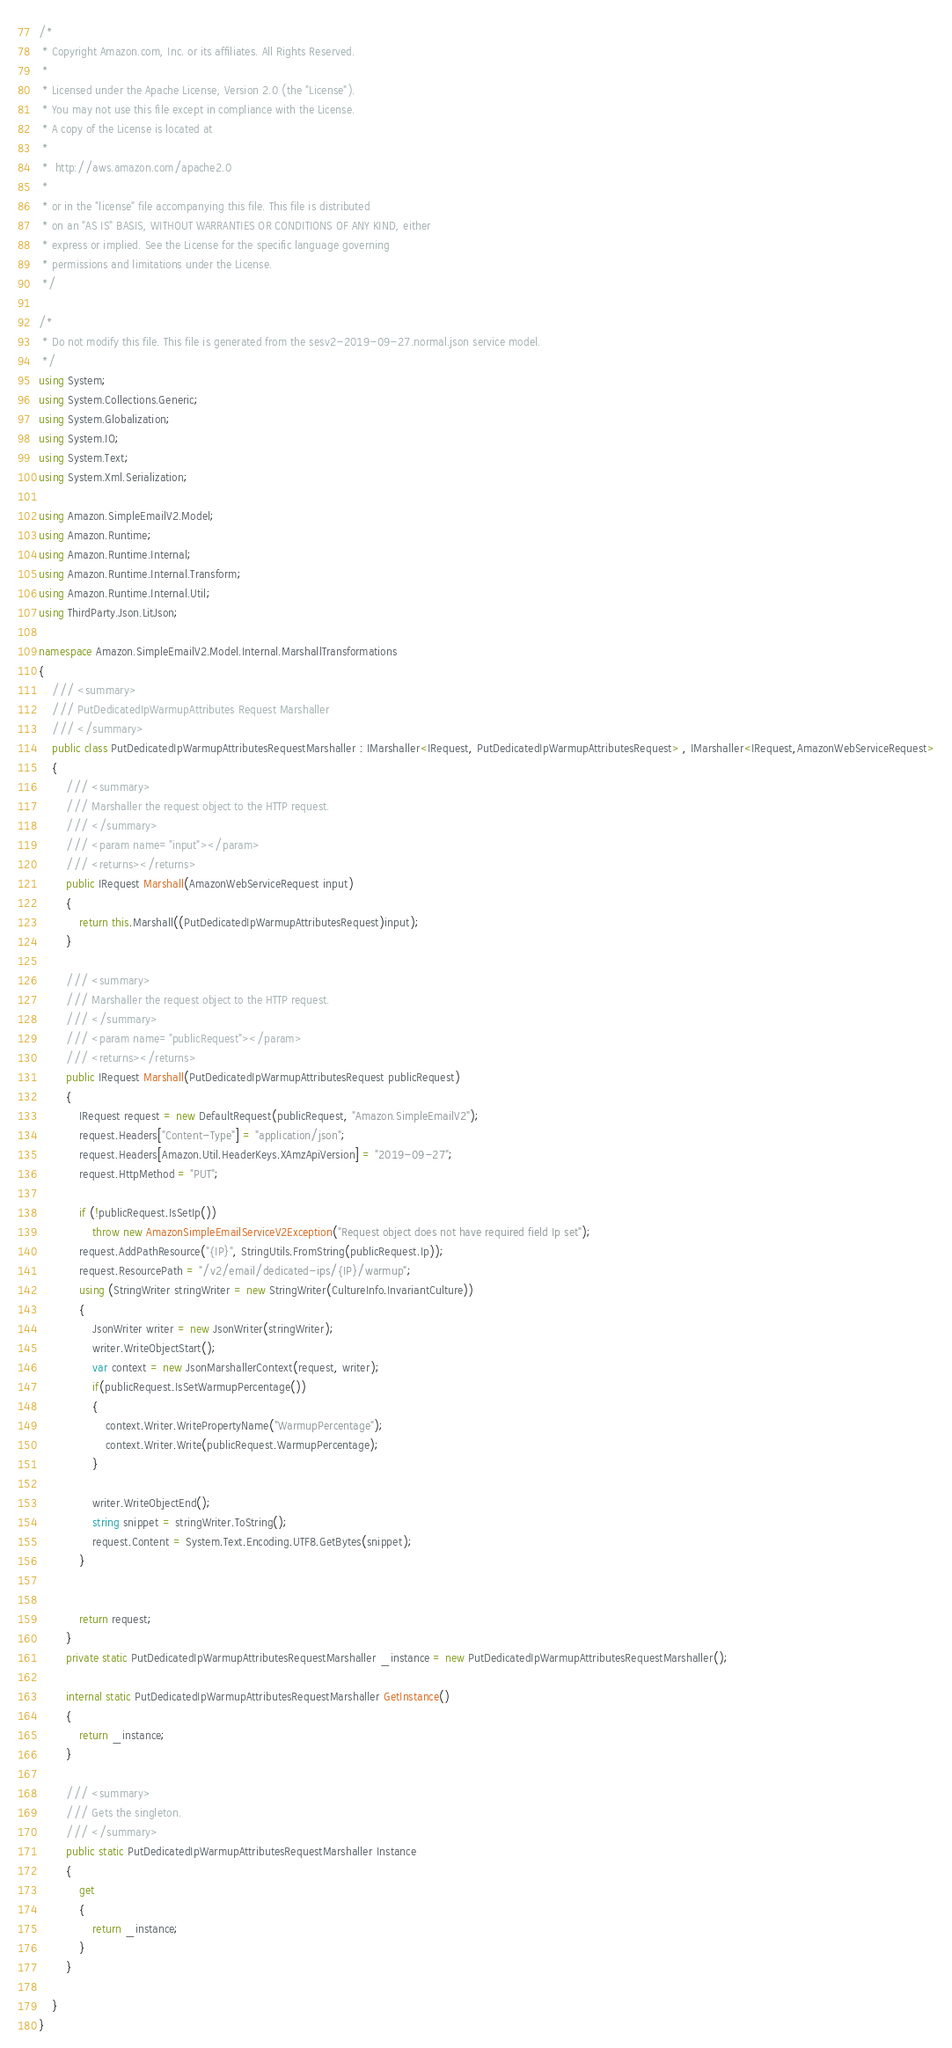Convert code to text. <code><loc_0><loc_0><loc_500><loc_500><_C#_>/*
 * Copyright Amazon.com, Inc. or its affiliates. All Rights Reserved.
 * 
 * Licensed under the Apache License, Version 2.0 (the "License").
 * You may not use this file except in compliance with the License.
 * A copy of the License is located at
 * 
 *  http://aws.amazon.com/apache2.0
 * 
 * or in the "license" file accompanying this file. This file is distributed
 * on an "AS IS" BASIS, WITHOUT WARRANTIES OR CONDITIONS OF ANY KIND, either
 * express or implied. See the License for the specific language governing
 * permissions and limitations under the License.
 */

/*
 * Do not modify this file. This file is generated from the sesv2-2019-09-27.normal.json service model.
 */
using System;
using System.Collections.Generic;
using System.Globalization;
using System.IO;
using System.Text;
using System.Xml.Serialization;

using Amazon.SimpleEmailV2.Model;
using Amazon.Runtime;
using Amazon.Runtime.Internal;
using Amazon.Runtime.Internal.Transform;
using Amazon.Runtime.Internal.Util;
using ThirdParty.Json.LitJson;

namespace Amazon.SimpleEmailV2.Model.Internal.MarshallTransformations
{
    /// <summary>
    /// PutDedicatedIpWarmupAttributes Request Marshaller
    /// </summary>       
    public class PutDedicatedIpWarmupAttributesRequestMarshaller : IMarshaller<IRequest, PutDedicatedIpWarmupAttributesRequest> , IMarshaller<IRequest,AmazonWebServiceRequest>
    {
        /// <summary>
        /// Marshaller the request object to the HTTP request.
        /// </summary>  
        /// <param name="input"></param>
        /// <returns></returns>
        public IRequest Marshall(AmazonWebServiceRequest input)
        {
            return this.Marshall((PutDedicatedIpWarmupAttributesRequest)input);
        }

        /// <summary>
        /// Marshaller the request object to the HTTP request.
        /// </summary>  
        /// <param name="publicRequest"></param>
        /// <returns></returns>
        public IRequest Marshall(PutDedicatedIpWarmupAttributesRequest publicRequest)
        {
            IRequest request = new DefaultRequest(publicRequest, "Amazon.SimpleEmailV2");
            request.Headers["Content-Type"] = "application/json";
            request.Headers[Amazon.Util.HeaderKeys.XAmzApiVersion] = "2019-09-27";
            request.HttpMethod = "PUT";

            if (!publicRequest.IsSetIp())
                throw new AmazonSimpleEmailServiceV2Exception("Request object does not have required field Ip set");
            request.AddPathResource("{IP}", StringUtils.FromString(publicRequest.Ip));
            request.ResourcePath = "/v2/email/dedicated-ips/{IP}/warmup";
            using (StringWriter stringWriter = new StringWriter(CultureInfo.InvariantCulture))
            {
                JsonWriter writer = new JsonWriter(stringWriter);
                writer.WriteObjectStart();
                var context = new JsonMarshallerContext(request, writer);
                if(publicRequest.IsSetWarmupPercentage())
                {
                    context.Writer.WritePropertyName("WarmupPercentage");
                    context.Writer.Write(publicRequest.WarmupPercentage);
                }

                writer.WriteObjectEnd();
                string snippet = stringWriter.ToString();
                request.Content = System.Text.Encoding.UTF8.GetBytes(snippet);
            }


            return request;
        }
        private static PutDedicatedIpWarmupAttributesRequestMarshaller _instance = new PutDedicatedIpWarmupAttributesRequestMarshaller();        

        internal static PutDedicatedIpWarmupAttributesRequestMarshaller GetInstance()
        {
            return _instance;
        }

        /// <summary>
        /// Gets the singleton.
        /// </summary>  
        public static PutDedicatedIpWarmupAttributesRequestMarshaller Instance
        {
            get
            {
                return _instance;
            }
        }

    }
}</code> 